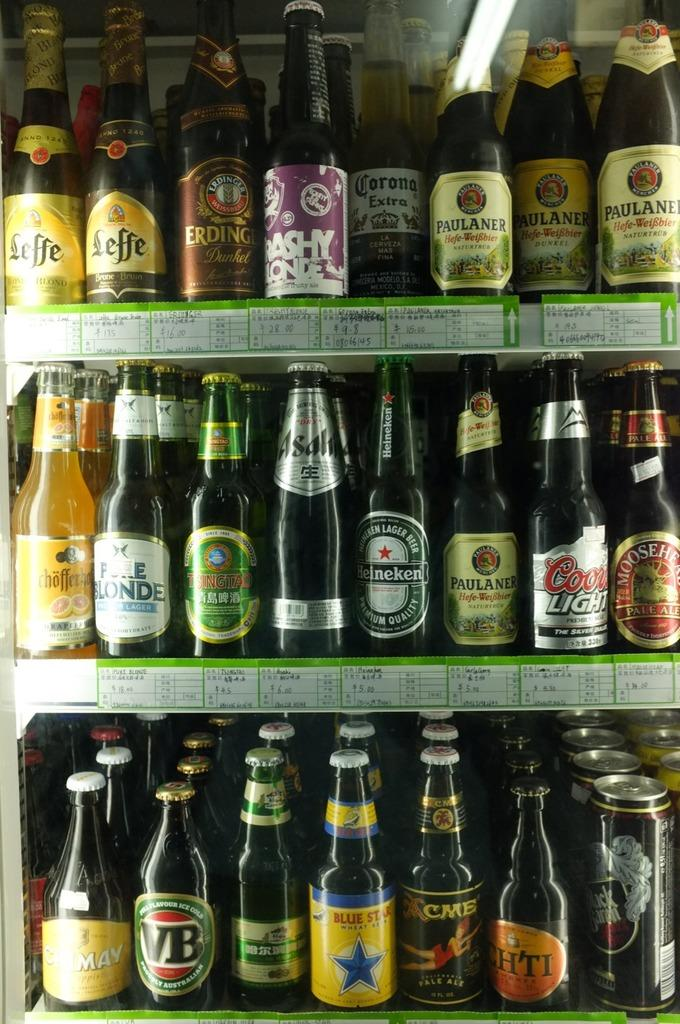Provide a one-sentence caption for the provided image. A collection of imported beers on shelves in a refrigerator. 